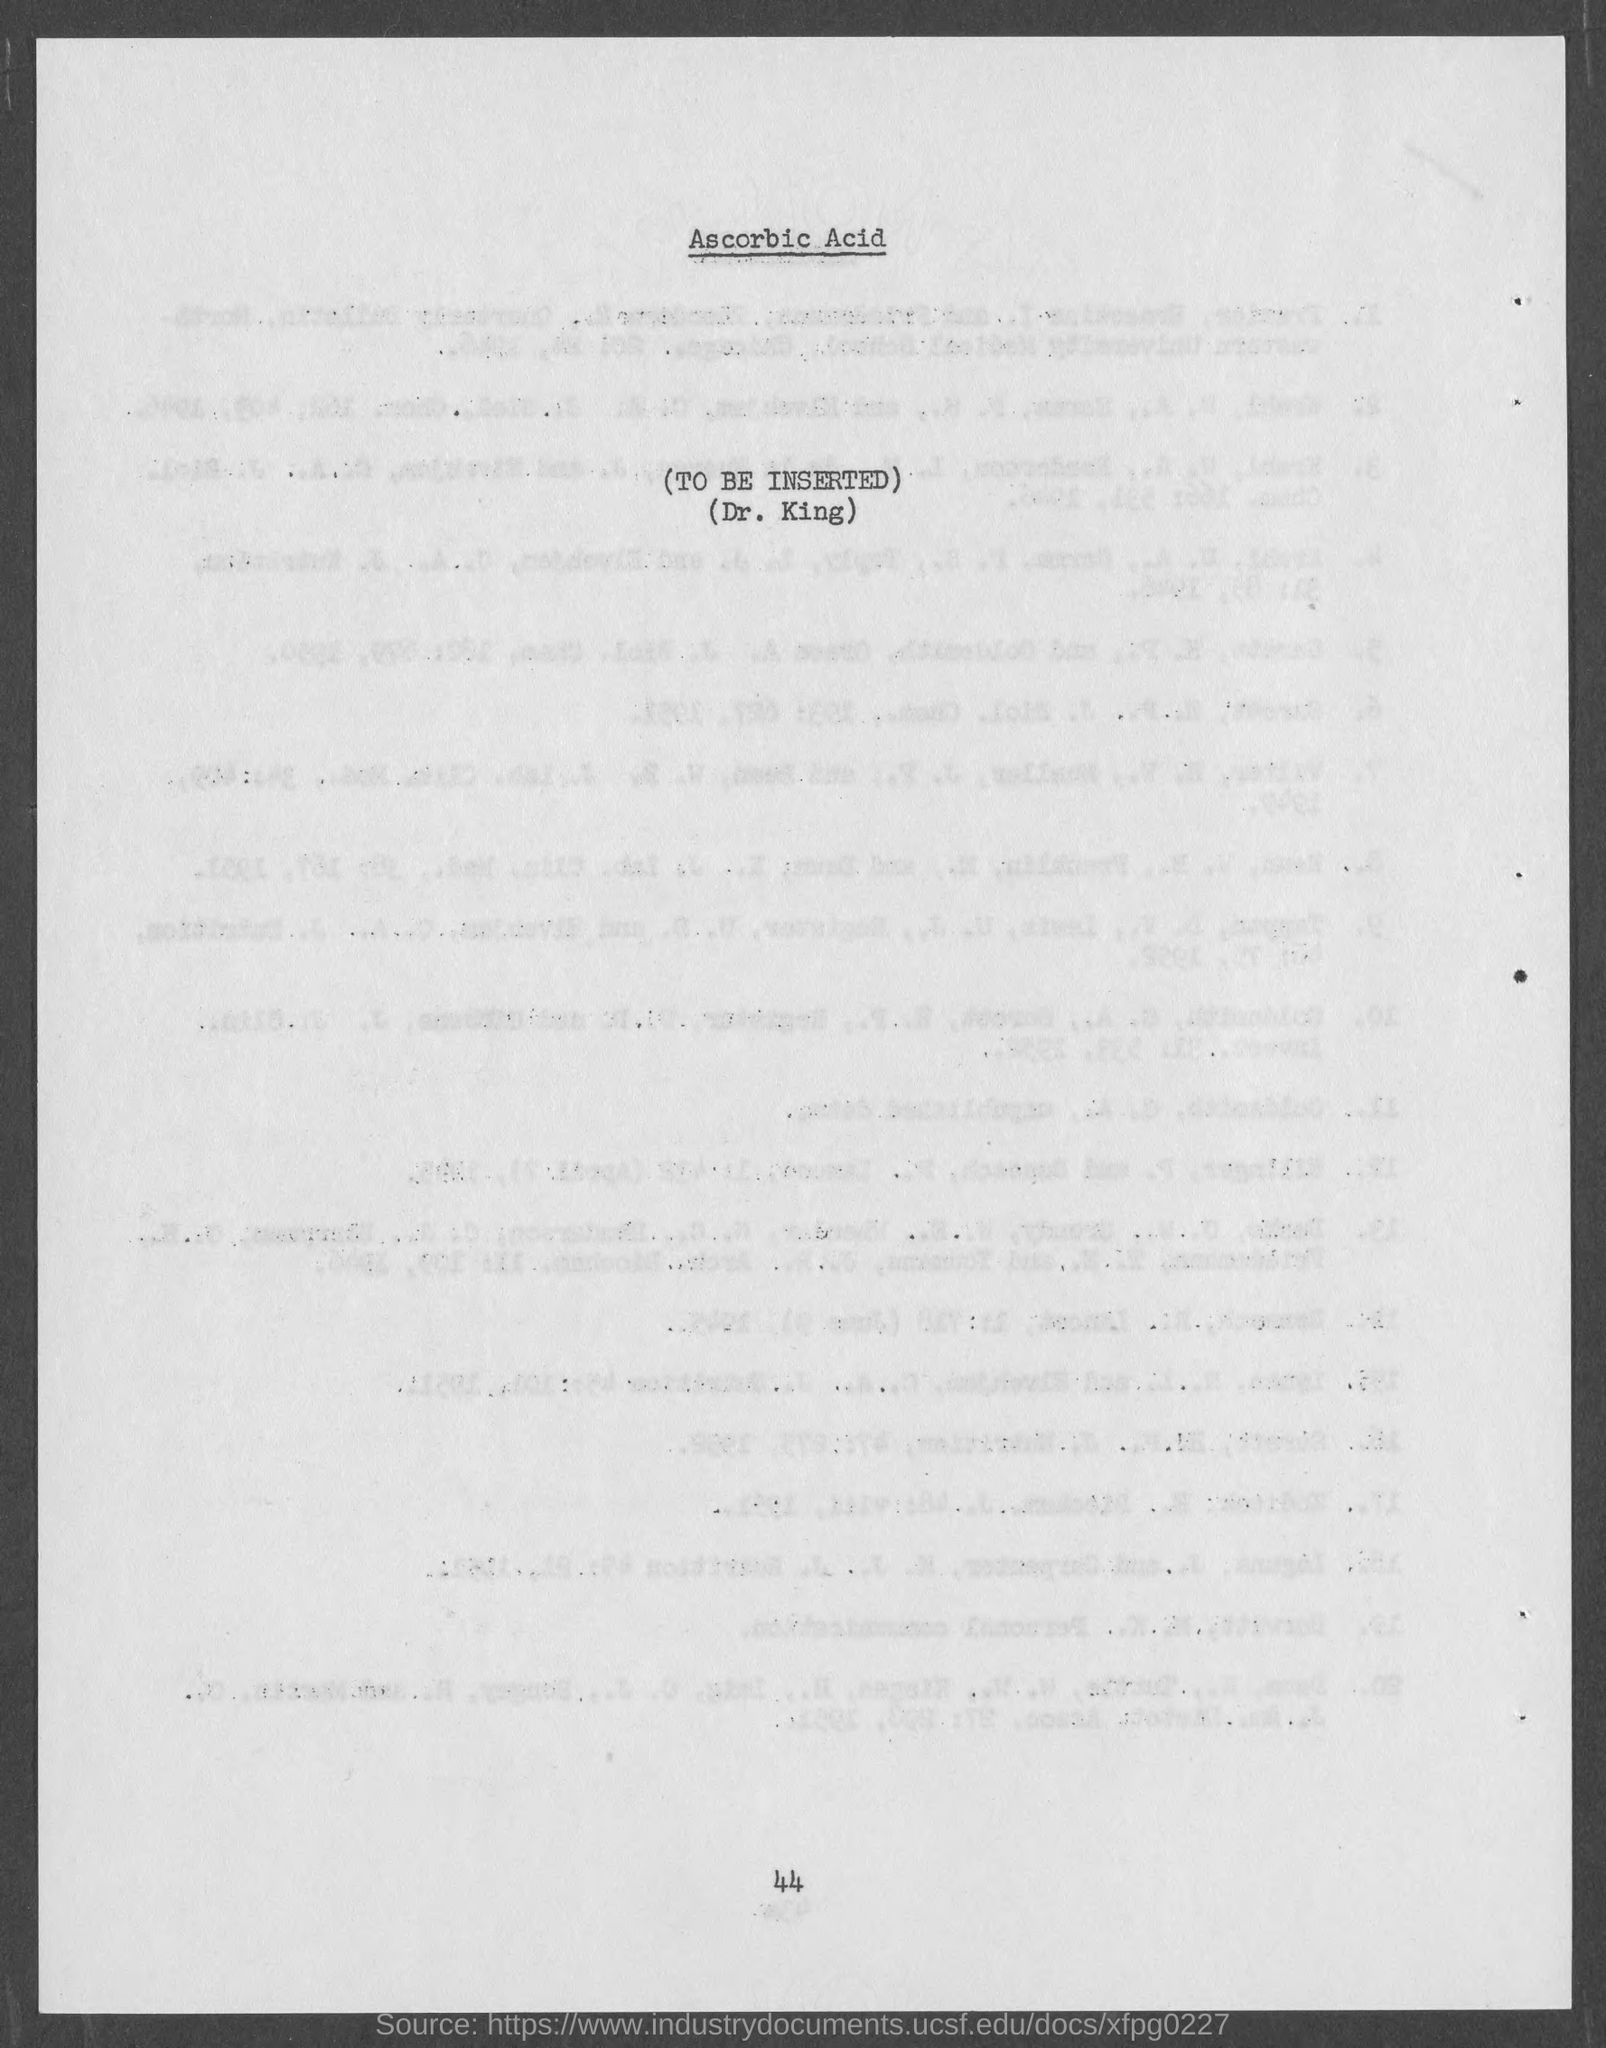Highlight a few significant elements in this photo. The page number at the bottom of the page is 44. 